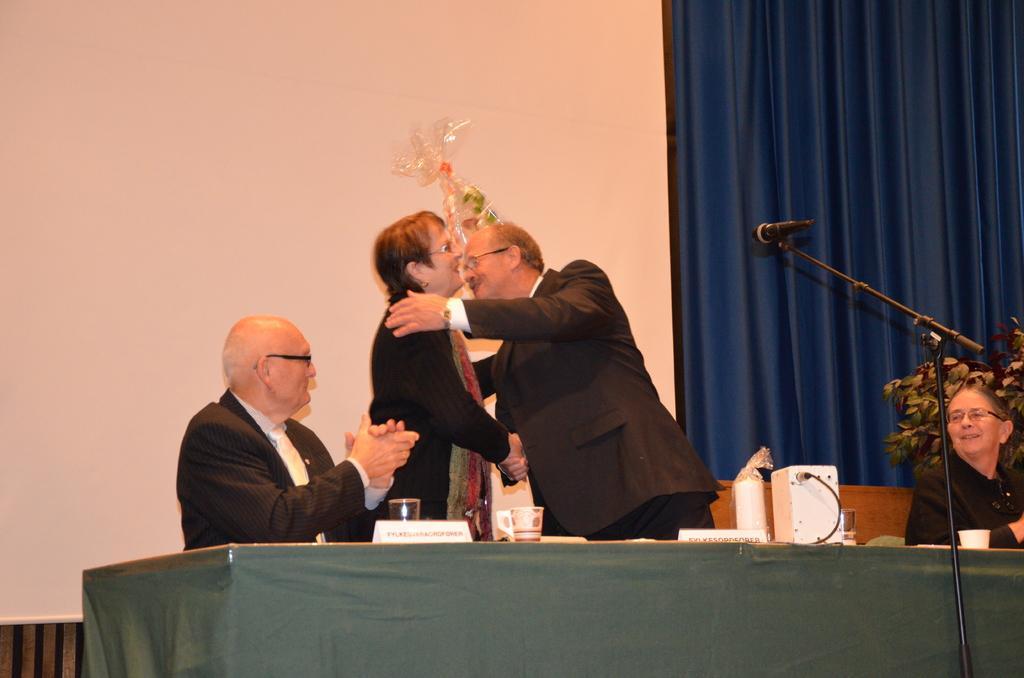Describe this image in one or two sentences. In this image there are persons sitting and standing. In the front there is a table which is covered with a green colour cloth. In front of the table there is a mic, on the table there is a white colour object and there is glass. In the background there is a curtain which is blue in colour. 